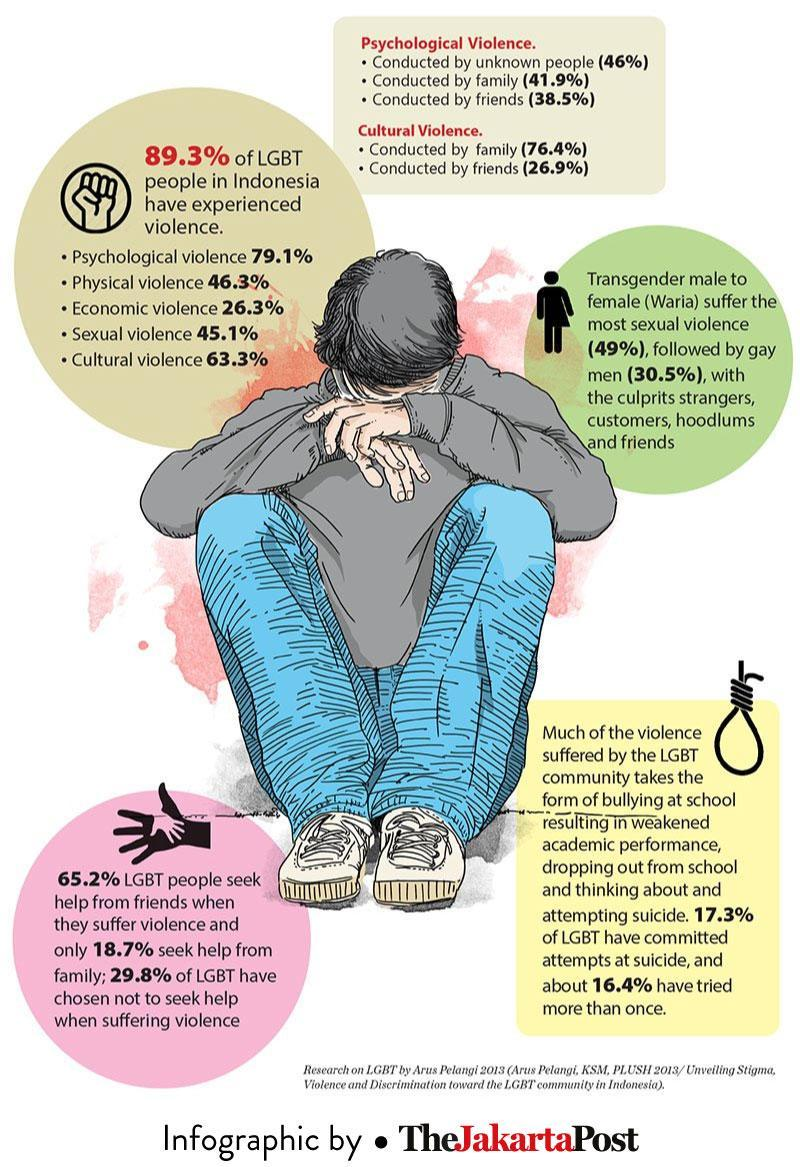What percentage of LGBT people have tried attempting suicide more than once?
Answer the question with a short phrase. 16.4% What percentage of LGBT people in Indonesia have experienced cultural violence? 63.3% What kind of violence the LGBT people are more succumbed to? Psychological violence What percentage of gay men suffer from sexual violence with the culprits strangers? 30.5% What percentage of LGBT people seek help from friends when they suffer violence? 65.2% What percentage of LGBT people seek help from family when they suffer violence? 18.7% What kind of violence the LGBT people are least succumbed to? Economic violence 